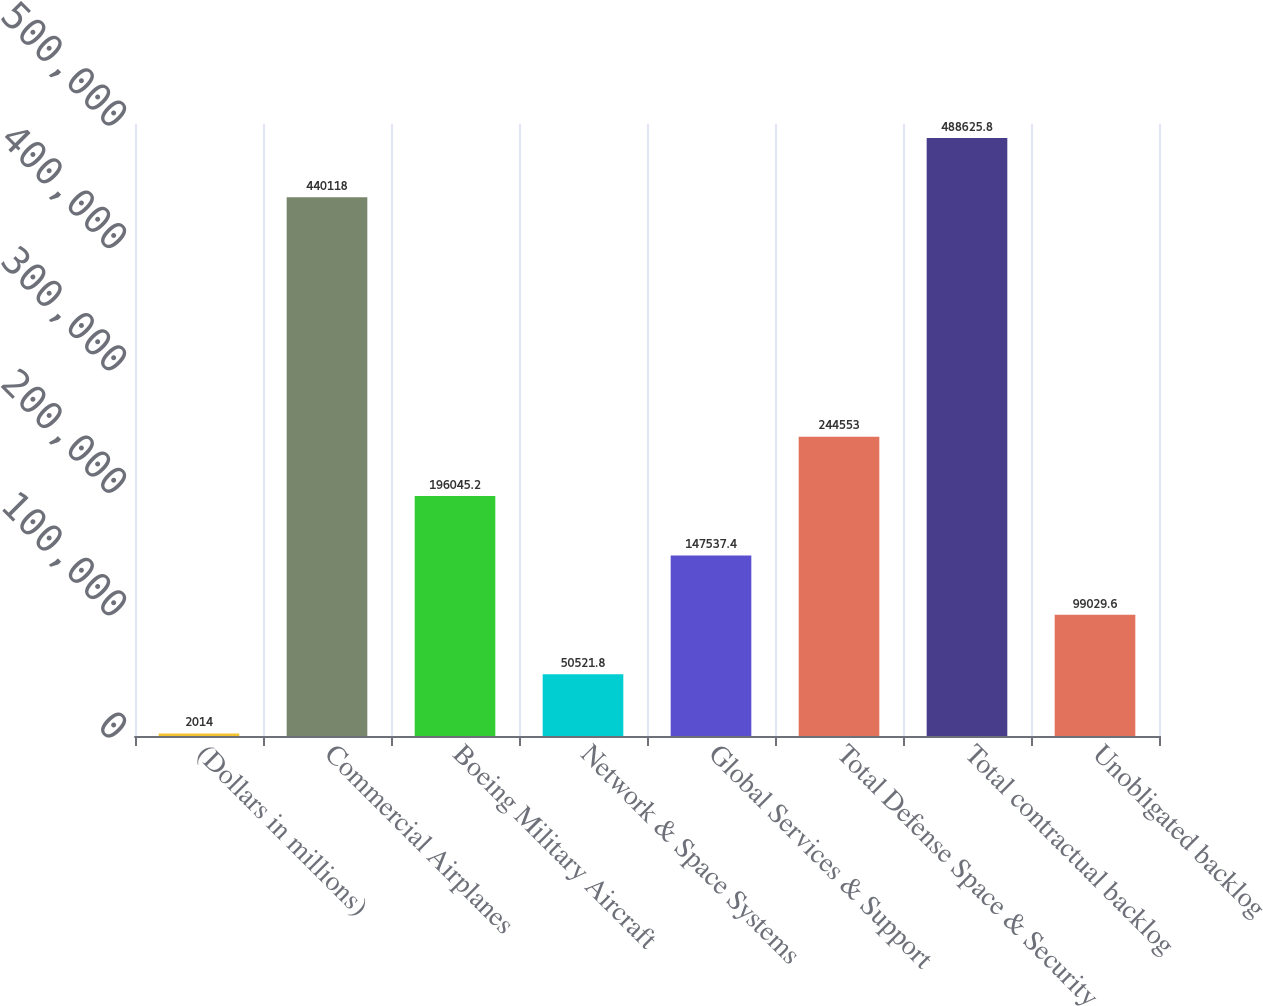Convert chart to OTSL. <chart><loc_0><loc_0><loc_500><loc_500><bar_chart><fcel>(Dollars in millions)<fcel>Commercial Airplanes<fcel>Boeing Military Aircraft<fcel>Network & Space Systems<fcel>Global Services & Support<fcel>Total Defense Space & Security<fcel>Total contractual backlog<fcel>Unobligated backlog<nl><fcel>2014<fcel>440118<fcel>196045<fcel>50521.8<fcel>147537<fcel>244553<fcel>488626<fcel>99029.6<nl></chart> 